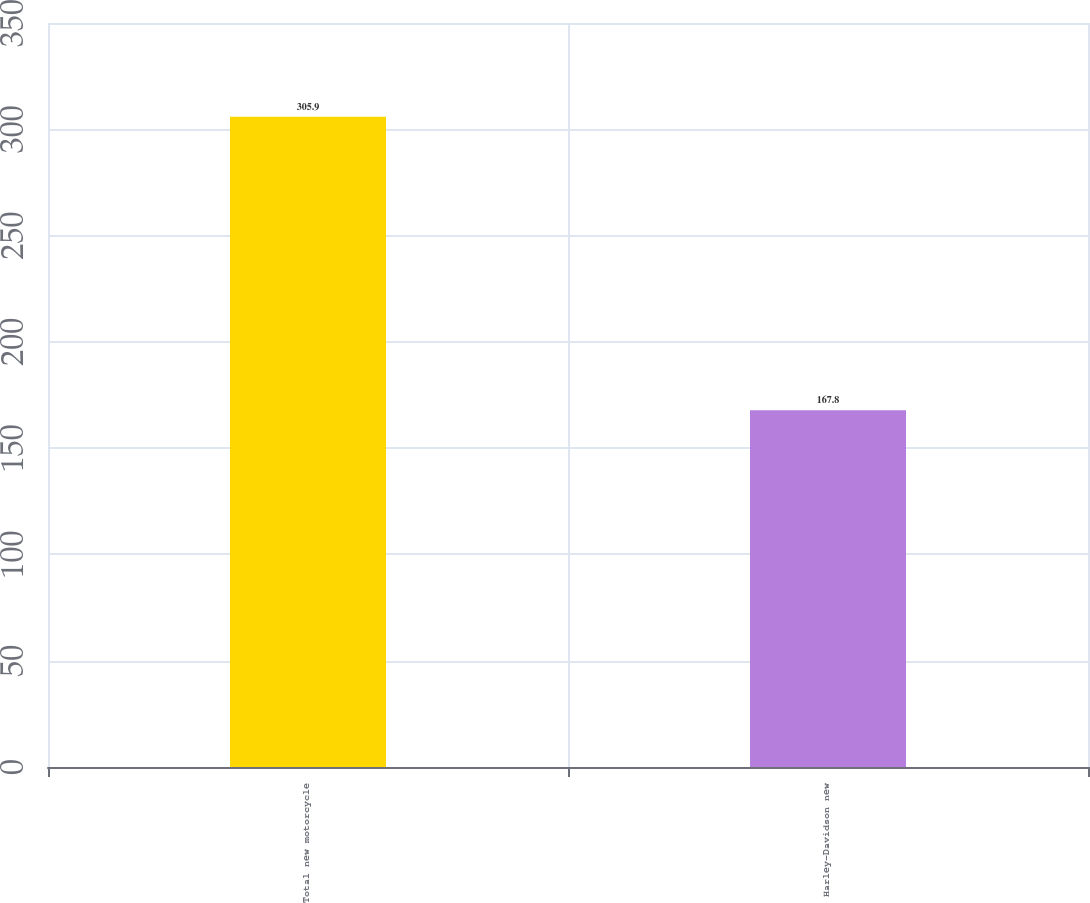Convert chart to OTSL. <chart><loc_0><loc_0><loc_500><loc_500><bar_chart><fcel>Total new motorcycle<fcel>Harley-Davidson new<nl><fcel>305.9<fcel>167.8<nl></chart> 